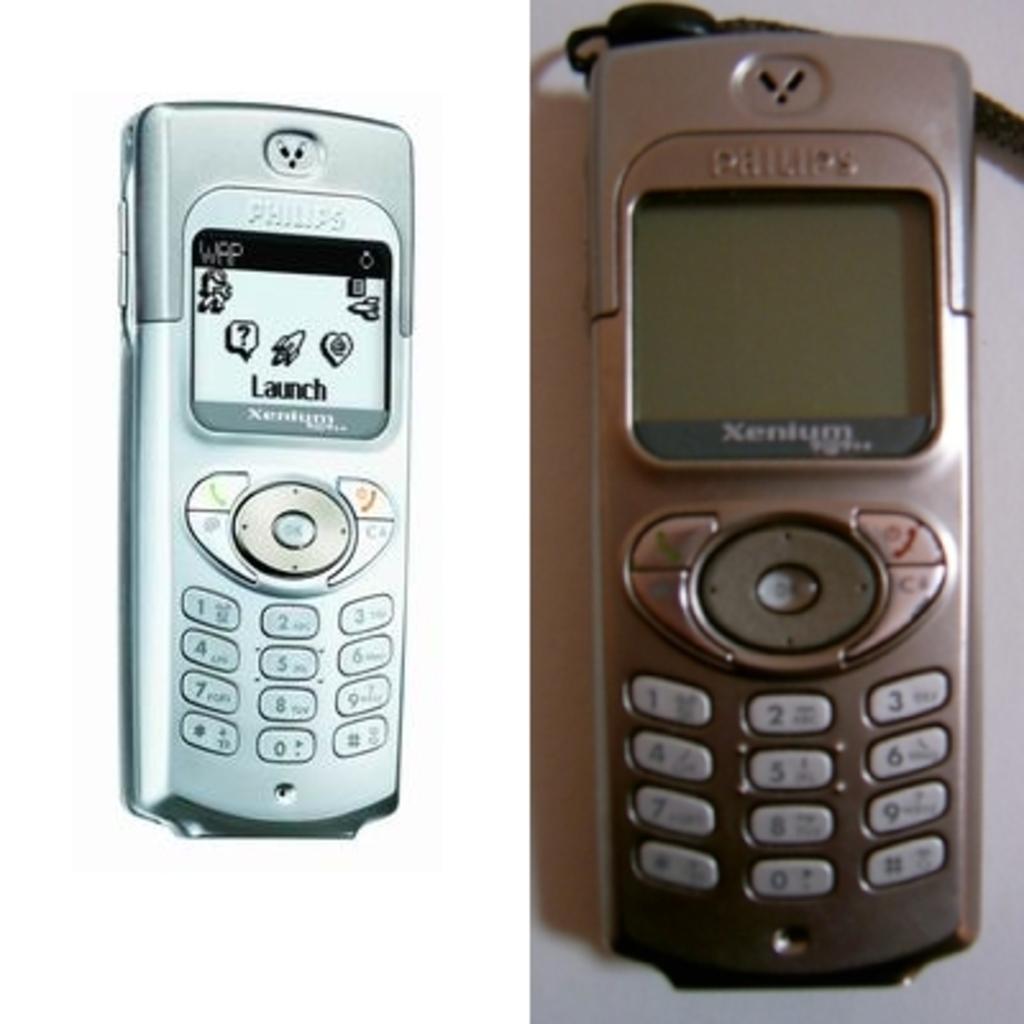Who makes this phone?
Provide a succinct answer. Philips. This is mobile?
Your response must be concise. Yes. 